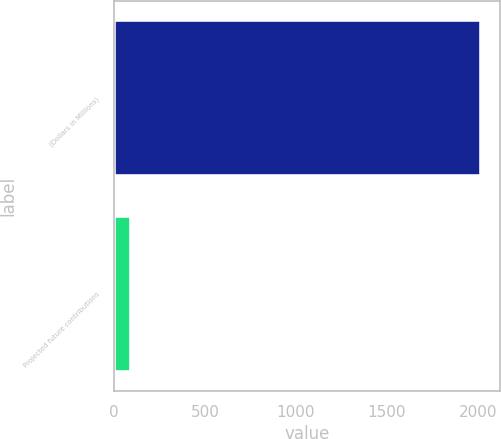<chart> <loc_0><loc_0><loc_500><loc_500><bar_chart><fcel>(Dollars in Millions)<fcel>Projected future contributions<nl><fcel>2019<fcel>92<nl></chart> 